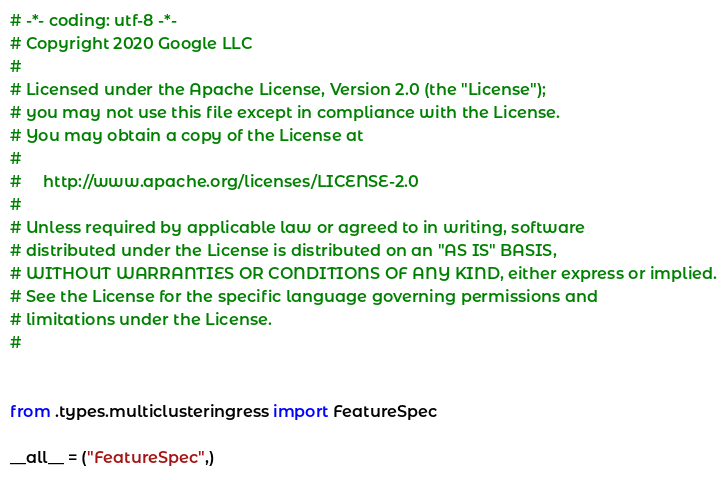Convert code to text. <code><loc_0><loc_0><loc_500><loc_500><_Python_># -*- coding: utf-8 -*-
# Copyright 2020 Google LLC
#
# Licensed under the Apache License, Version 2.0 (the "License");
# you may not use this file except in compliance with the License.
# You may obtain a copy of the License at
#
#     http://www.apache.org/licenses/LICENSE-2.0
#
# Unless required by applicable law or agreed to in writing, software
# distributed under the License is distributed on an "AS IS" BASIS,
# WITHOUT WARRANTIES OR CONDITIONS OF ANY KIND, either express or implied.
# See the License for the specific language governing permissions and
# limitations under the License.
#


from .types.multiclusteringress import FeatureSpec

__all__ = ("FeatureSpec",)
</code> 